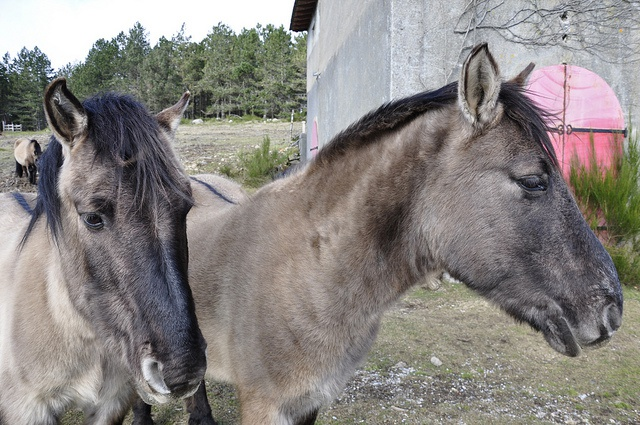Describe the objects in this image and their specific colors. I can see horse in white, gray, darkgray, and black tones, horse in white, gray, darkgray, black, and lightgray tones, and horse in white, black, lightgray, gray, and darkgray tones in this image. 